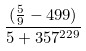<formula> <loc_0><loc_0><loc_500><loc_500>\frac { ( \frac { 5 } { 9 } - 4 9 9 ) } { 5 + 3 5 7 ^ { 2 2 9 } }</formula> 